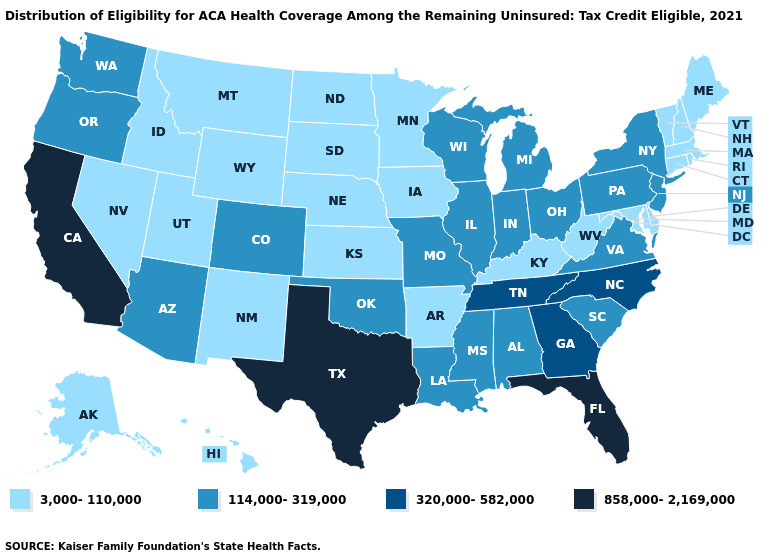Name the states that have a value in the range 858,000-2,169,000?
Answer briefly. California, Florida, Texas. What is the value of New Jersey?
Keep it brief. 114,000-319,000. Which states hav the highest value in the Northeast?
Short answer required. New Jersey, New York, Pennsylvania. Among the states that border Wisconsin , does Michigan have the lowest value?
Keep it brief. No. Among the states that border New Mexico , does Oklahoma have the lowest value?
Short answer required. No. Name the states that have a value in the range 3,000-110,000?
Concise answer only. Alaska, Arkansas, Connecticut, Delaware, Hawaii, Idaho, Iowa, Kansas, Kentucky, Maine, Maryland, Massachusetts, Minnesota, Montana, Nebraska, Nevada, New Hampshire, New Mexico, North Dakota, Rhode Island, South Dakota, Utah, Vermont, West Virginia, Wyoming. What is the value of New Hampshire?
Quick response, please. 3,000-110,000. Does Missouri have the highest value in the USA?
Write a very short answer. No. What is the value of Louisiana?
Give a very brief answer. 114,000-319,000. Name the states that have a value in the range 320,000-582,000?
Keep it brief. Georgia, North Carolina, Tennessee. Is the legend a continuous bar?
Give a very brief answer. No. Does Virginia have the same value as Wyoming?
Write a very short answer. No. Which states have the highest value in the USA?
Short answer required. California, Florida, Texas. Among the states that border New York , does Pennsylvania have the lowest value?
Give a very brief answer. No. Among the states that border Minnesota , which have the lowest value?
Write a very short answer. Iowa, North Dakota, South Dakota. 